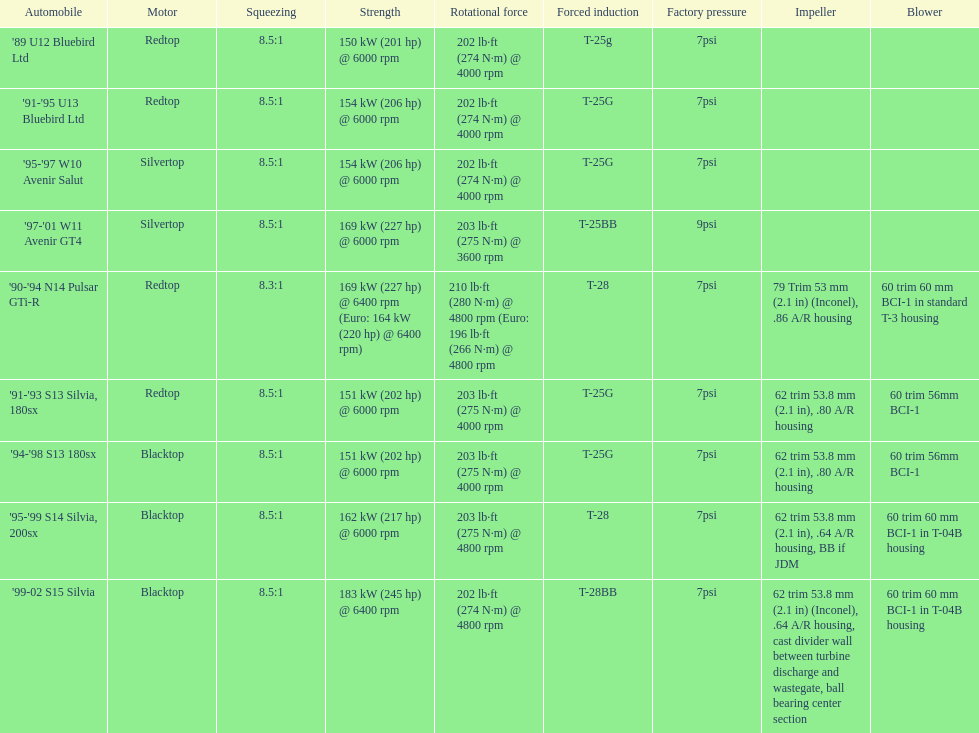What is his/her compression for the 90-94 n14 pulsar gti-r? 8.3:1. 